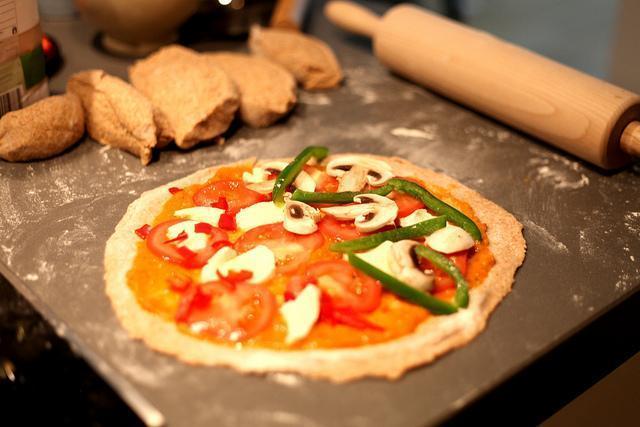How many faces of the clock can you see completely?
Give a very brief answer. 0. 